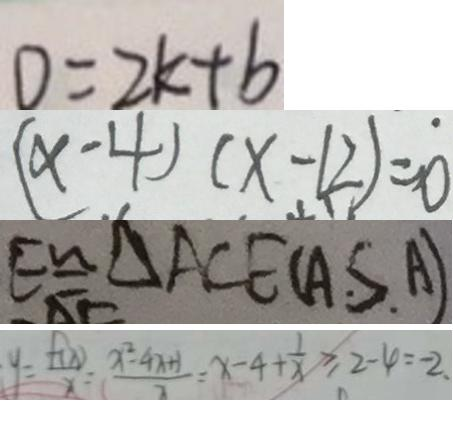Convert formula to latex. <formula><loc_0><loc_0><loc_500><loc_500>D = 2 k + b 
 ( x - 4 ) ( x - 1 2 ) = 0 
 E \cong \Delta A C E ( A . S . A ) 
 y = \frac { f ( x ) } { x } = \frac { x ^ { 2 } - 4 x + 1 } { x } = x - 4 + \frac { 1 } { x } \geq 2 - 4 = - 2 .</formula> 